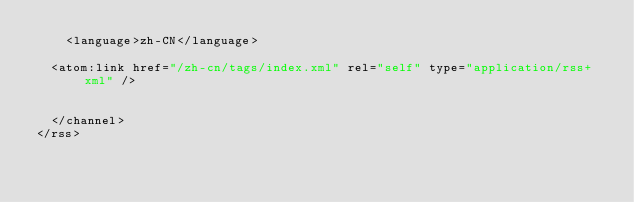Convert code to text. <code><loc_0><loc_0><loc_500><loc_500><_XML_>    <language>zh-CN</language>
    
	<atom:link href="/zh-cn/tags/index.xml" rel="self" type="application/rss+xml" />
    
    
  </channel>
</rss></code> 